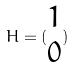Convert formula to latex. <formula><loc_0><loc_0><loc_500><loc_500>H = ( \begin{matrix} 1 \\ 0 \end{matrix} )</formula> 